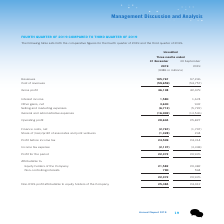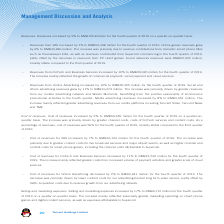According to Tencent's financial document, What was the primary reason for the increase in VAS revenues? The increase was primarily due to revenue contributions from domestic smart phone titles such as Peacekeeper Elite, as well as revenues contributed from Supercell commencing in the fourth quarter of 2019, partly offset by the decrease in revenues from PC client games.. The document states: "by 6% to RMB30,286 million. The increase was primarily due to revenue contributions from domestic smart phone titles such as Peacekeeper Elite, as wel..." Also, What was the primary reason for the increase in FinTech and Business Services revenue? The increase mainly reflected the growth of commercial payment, social payment and cloud services.. The document states: "The increase mainly reflected the growth of commercial payment, social payment and cloud services...." Also, What was the primary reason for the increase in Online Advertising revenue? The increase was primarily driven by greater revenues from our mobile advertising network and Weixin Moments, benefitting from the positive seasonality of eCommerce promotional activities in the fourth quarter.. The document states: "rtising revenues grew by 11% to RMB16,274 million. The increase was primarily driven by greater revenues from our mobile advertising network and Weixi..." Also, can you calculate: What is the profit margin for the fourth quarter of 2019? Based on the calculation: 22,372/105,767, the result is 21.15 (percentage). This is based on the information: "Profit for the period 22,372 20,976 Revenues 105,767 97,236..." The key data points involved are: 105,767, 22,372. Also, can you calculate: What is the profit margin for the third quarter of 2019? Based on the calculation: 20,976/97,236, the result is 21.57 (percentage). This is based on the information: "Revenues 105,767 97,236 Profit for the period 22,372 20,976..." The key data points involved are: 20,976, 97,236. Also, can you calculate: What percentage of fourth quarter profits is the profits attributable to equity holders of the company? Based on the calculation: 21,582/22,372, the result is 96.47 (percentage). This is based on the information: "Profit for the period 22,372 20,976 Equity holders of the Company 21,582 20,382..." The key data points involved are: 21,582, 22,372. 